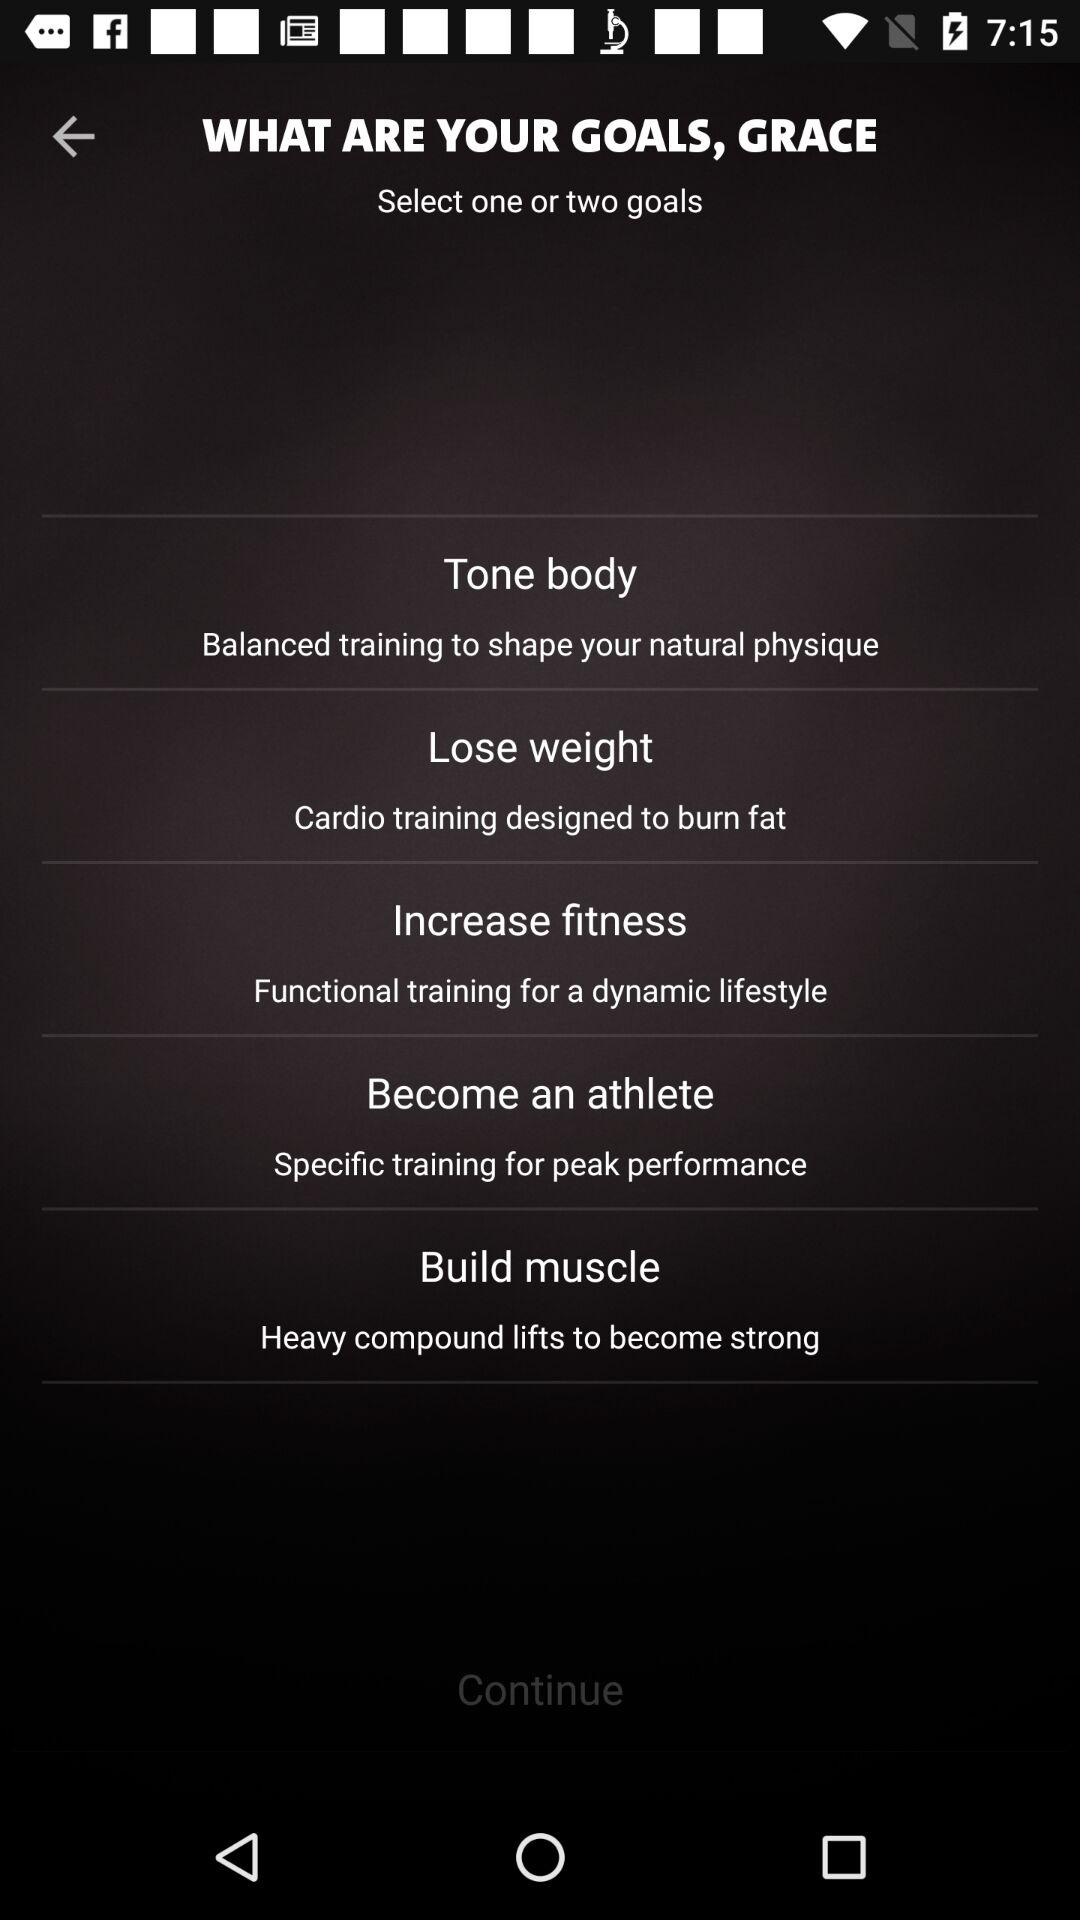What is the name of the user? The name of the user is Grace. 